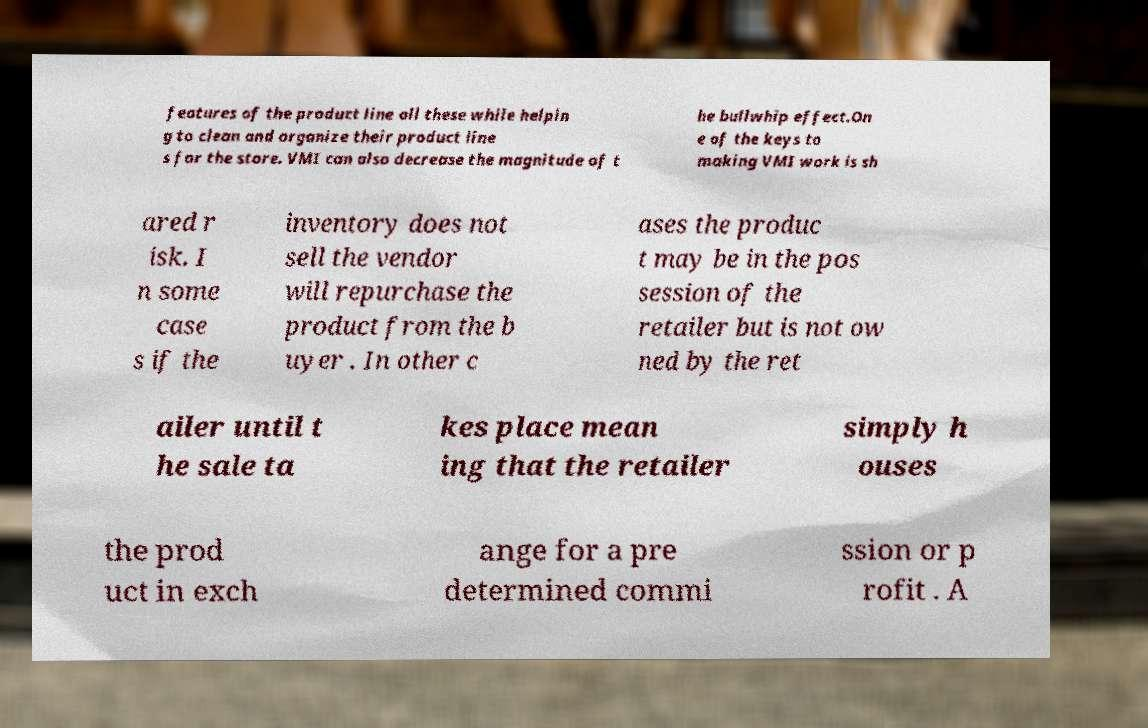Could you assist in decoding the text presented in this image and type it out clearly? features of the product line all these while helpin g to clean and organize their product line s for the store. VMI can also decrease the magnitude of t he bullwhip effect.On e of the keys to making VMI work is sh ared r isk. I n some case s if the inventory does not sell the vendor will repurchase the product from the b uyer . In other c ases the produc t may be in the pos session of the retailer but is not ow ned by the ret ailer until t he sale ta kes place mean ing that the retailer simply h ouses the prod uct in exch ange for a pre determined commi ssion or p rofit . A 